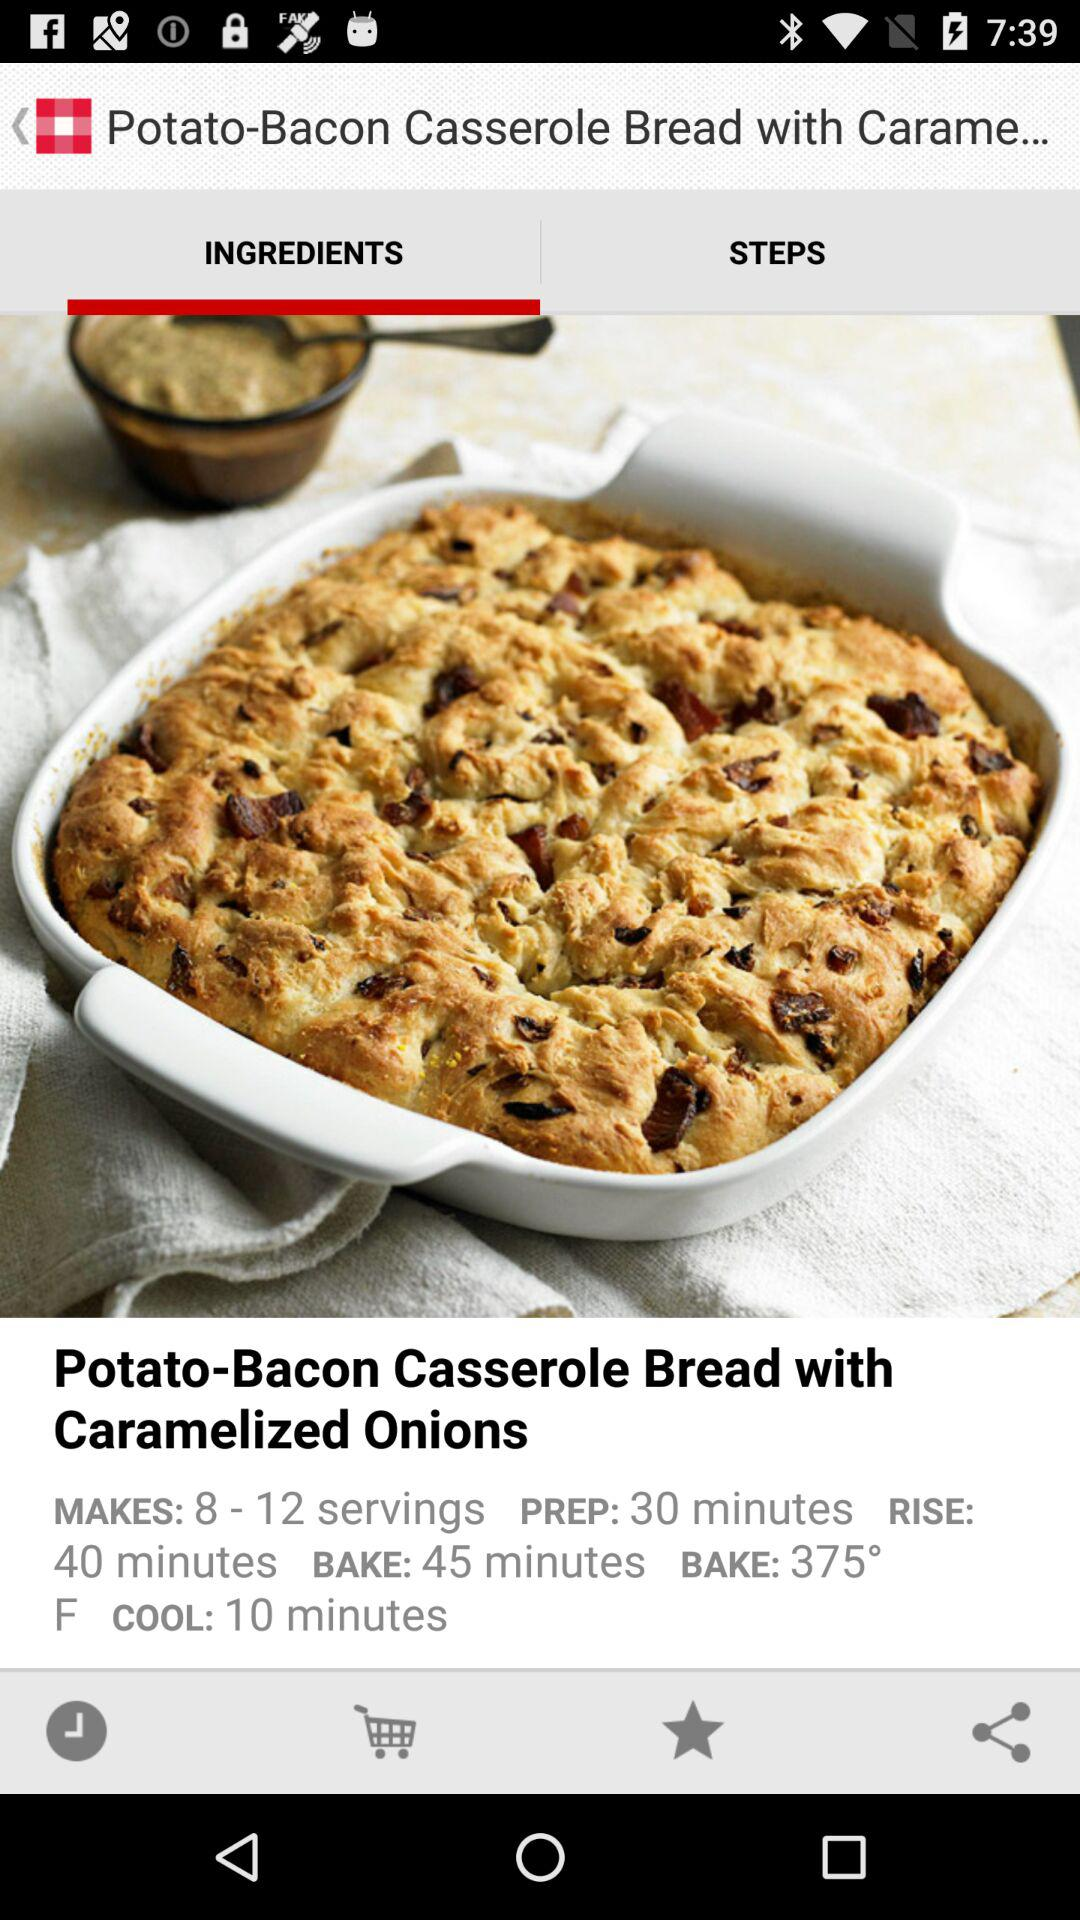How many servings does this recipe make?
Answer the question using a single word or phrase. 8-12 